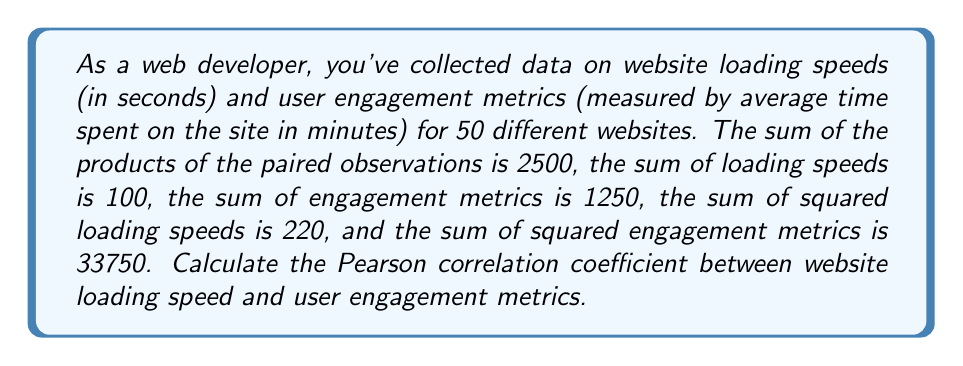Give your solution to this math problem. Let's approach this step-by-step using the formula for the Pearson correlation coefficient:

1) The formula for Pearson's r is:

   $$r = \frac{n\sum xy - \sum x \sum y}{\sqrt{[n\sum x^2 - (\sum x)^2][n\sum y^2 - (\sum y)^2]}}$$

   Where:
   $n$ = number of pairs of scores
   $\sum xy$ = sum of the products of paired scores
   $\sum x$ = sum of x scores
   $\sum y$ = sum of y scores
   $\sum x^2$ = sum of squared x scores
   $\sum y^2$ = sum of squared y scores

2) We're given:
   $n = 50$
   $\sum xy = 2500$
   $\sum x = 100$ (loading speeds)
   $\sum y = 1250$ (engagement metrics)
   $\sum x^2 = 220$
   $\sum y^2 = 33750$

3) Let's calculate the numerator:
   $n\sum xy - \sum x \sum y = 50(2500) - 100(1250) = 125000 - 125000 = 0$

4) Now for the denominator:
   $[n\sum x^2 - (\sum x)^2] = [50(220) - 100^2] = 11000 - 10000 = 1000$
   $[n\sum y^2 - (\sum y)^2] = [50(33750) - 1250^2] = 1687500 - 1562500 = 125000$

5) Combining these:
   $\sqrt{[n\sum x^2 - (\sum x)^2][n\sum y^2 - (\sum y)^2]} = \sqrt{1000 * 125000} = \sqrt{125000000} = 11180.34$

6) Finally, we can compute r:
   $$r = \frac{0}{11180.34} = 0$$
Answer: $r = 0$ 